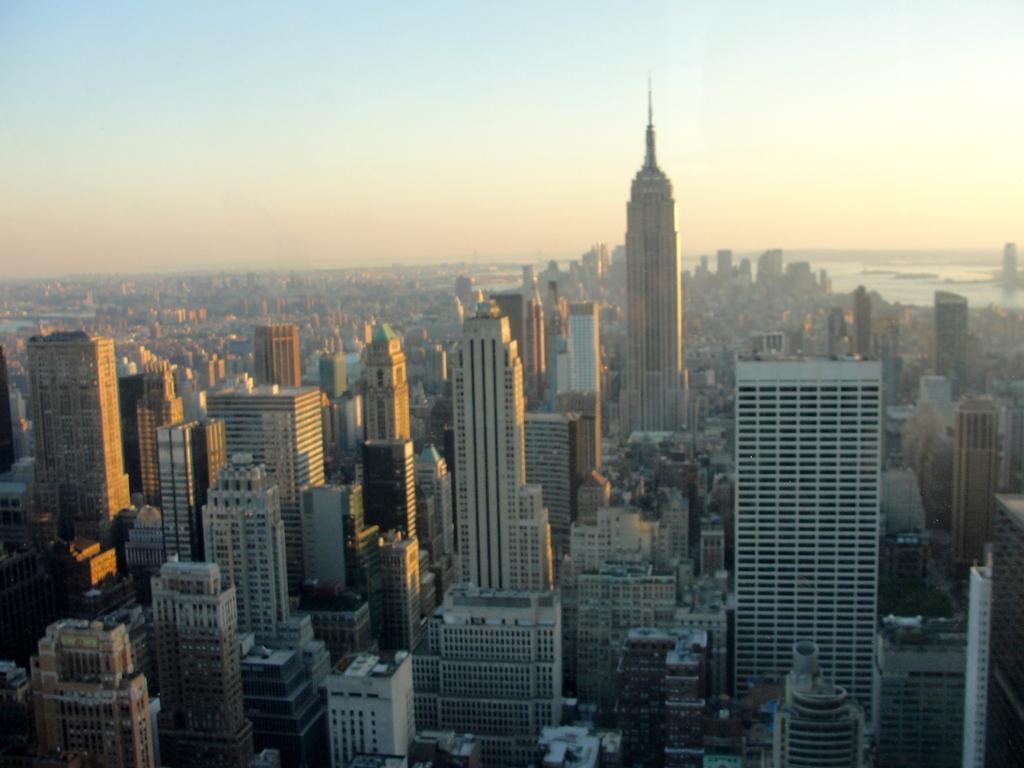How would you summarize this image in a sentence or two? In this image there are buildings. In the background of the image there is water and sky. 